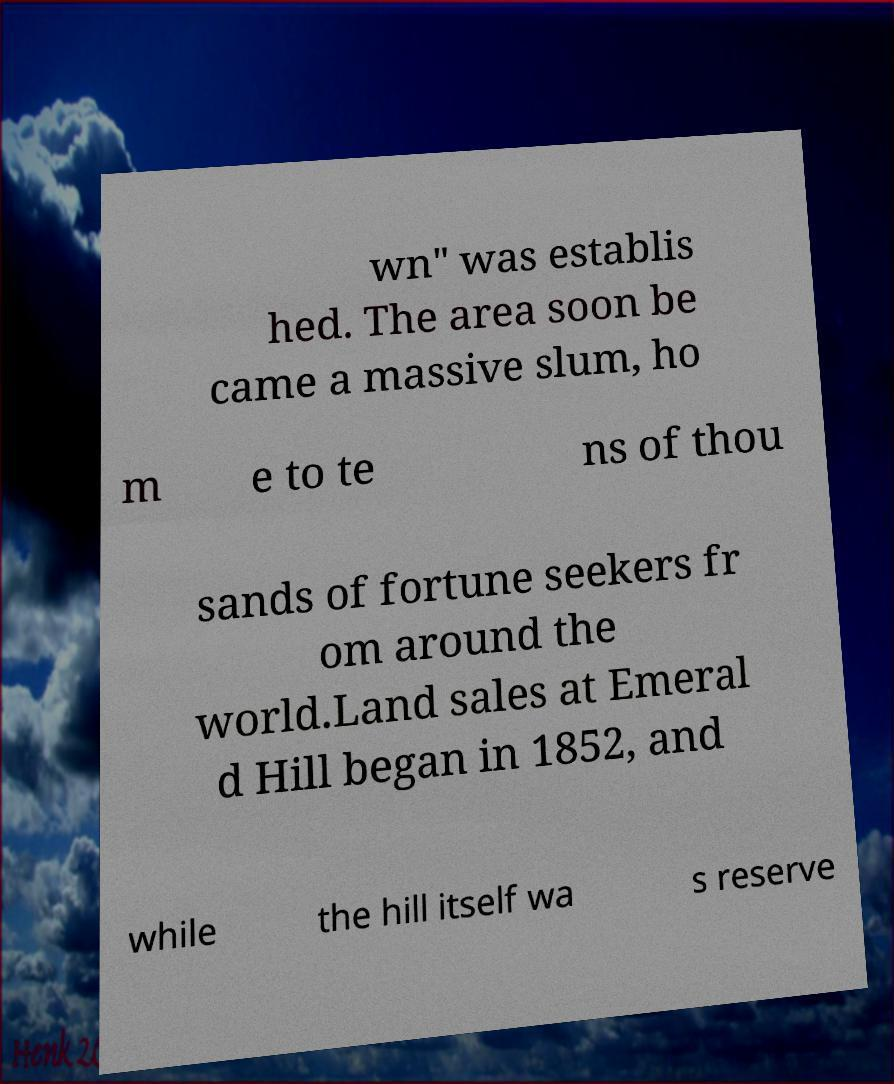Can you read and provide the text displayed in the image?This photo seems to have some interesting text. Can you extract and type it out for me? wn" was establis hed. The area soon be came a massive slum, ho m e to te ns of thou sands of fortune seekers fr om around the world.Land sales at Emeral d Hill began in 1852, and while the hill itself wa s reserve 